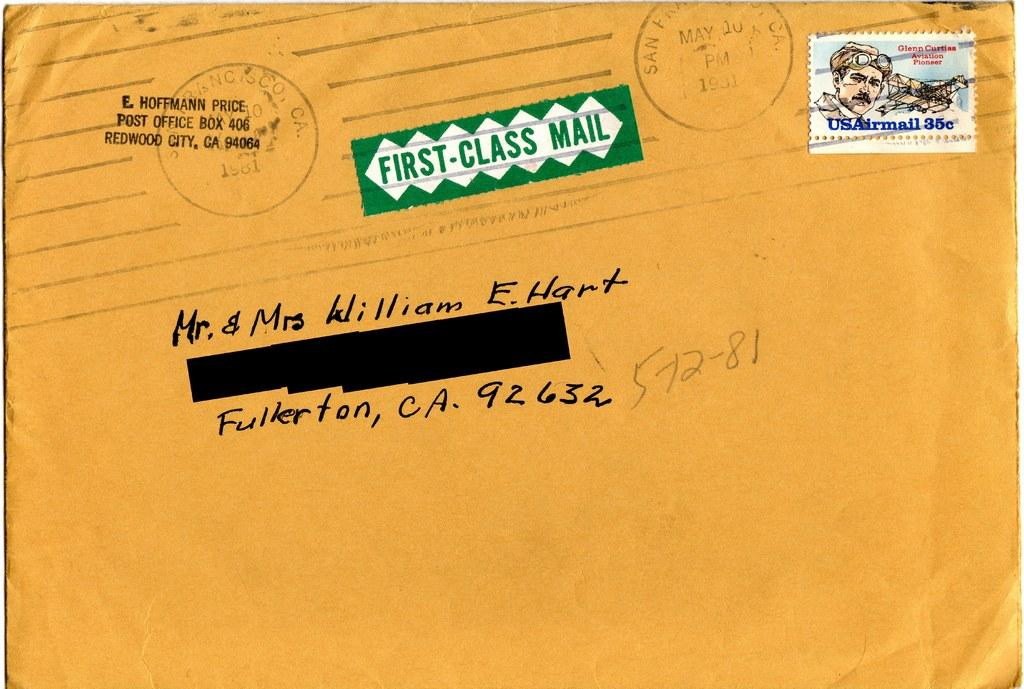<image>
Describe the image concisely. a yellow envelope for Mr and Mrs Willam E. Hart in Fullerton 